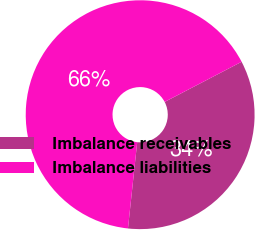Convert chart to OTSL. <chart><loc_0><loc_0><loc_500><loc_500><pie_chart><fcel>Imbalance receivables<fcel>Imbalance liabilities<nl><fcel>34.35%<fcel>65.65%<nl></chart> 